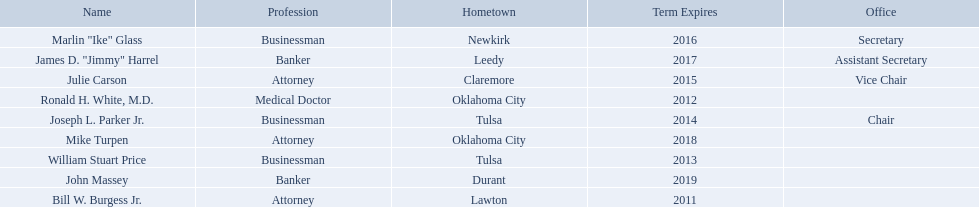What businessmen were born in tulsa? William Stuart Price, Joseph L. Parker Jr. Which man, other than price, was born in tulsa? Joseph L. Parker Jr. 